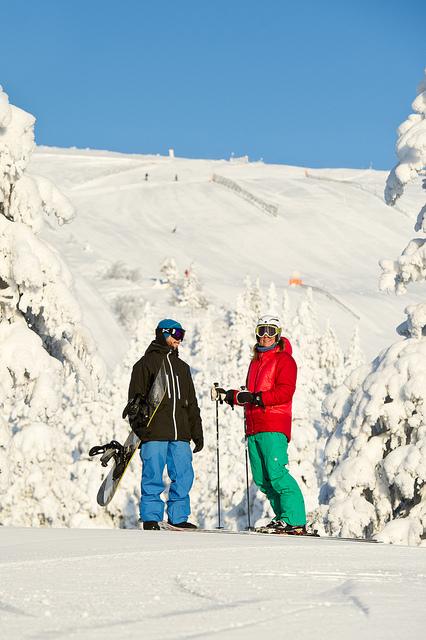What kind of trees are under all that snow?
Give a very brief answer. Pine. What color is the ground?
Write a very short answer. White. Is it cloudy?
Answer briefly. No. 